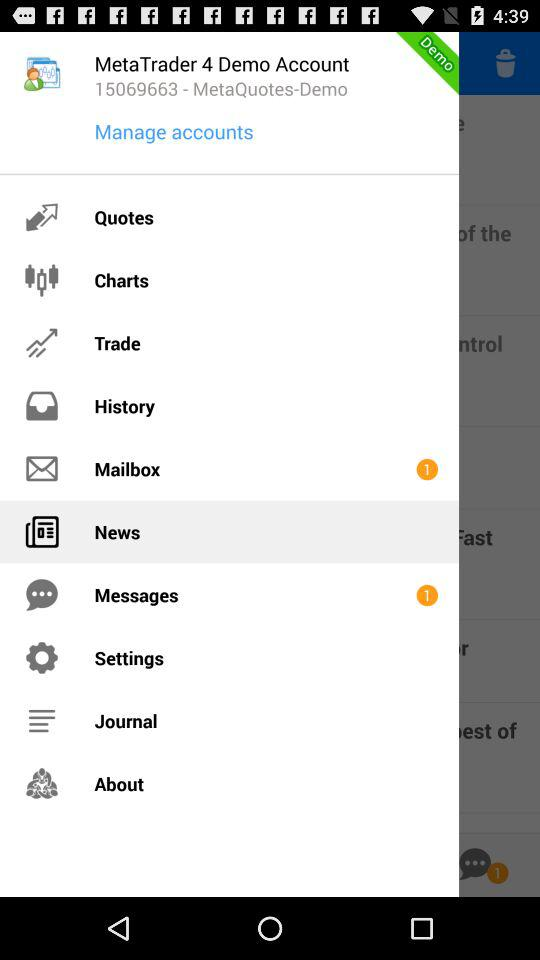What is the given code for "MetaQuotes-Demo"? The given code for "MetaQuotes-Demo" is 15069663. 